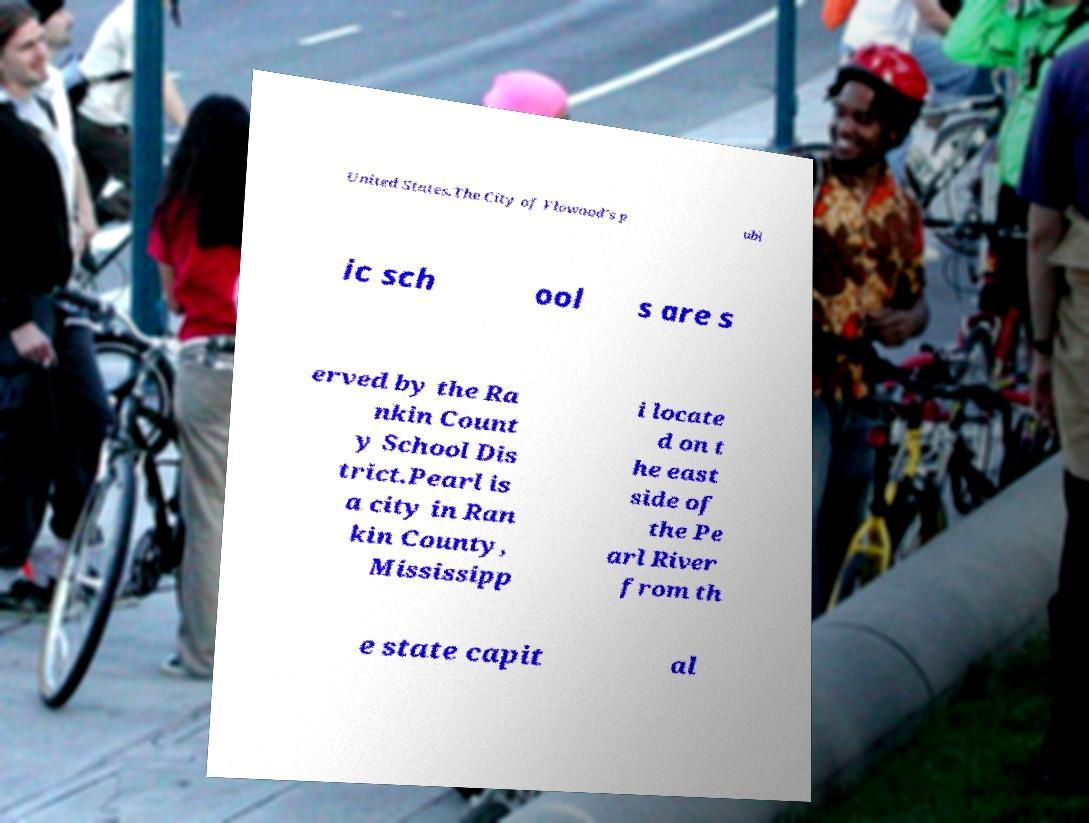Can you accurately transcribe the text from the provided image for me? United States.The City of Flowood's p ubl ic sch ool s are s erved by the Ra nkin Count y School Dis trict.Pearl is a city in Ran kin County, Mississipp i locate d on t he east side of the Pe arl River from th e state capit al 